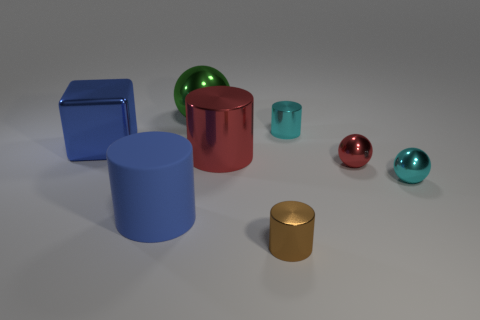What material is the other sphere that is the same size as the red metal sphere?
Keep it short and to the point. Metal. The cylinder to the right of the brown cylinder is what color?
Give a very brief answer. Cyan. What number of cyan metal things are there?
Give a very brief answer. 2. Is there a tiny cyan metallic sphere behind the metal sphere that is to the left of the shiny cylinder that is behind the big blue shiny object?
Your answer should be compact. No. The brown shiny thing that is the same size as the red sphere is what shape?
Ensure brevity in your answer.  Cylinder. What number of other things are there of the same color as the big cube?
Offer a terse response. 1. What is the big blue cylinder made of?
Provide a short and direct response. Rubber. What number of other things are there of the same material as the small cyan cylinder
Provide a succinct answer. 6. What size is the metallic sphere that is behind the tiny cyan sphere and in front of the big green object?
Offer a terse response. Small. There is a thing on the right side of the red metal object in front of the red cylinder; what shape is it?
Your answer should be very brief. Sphere. 